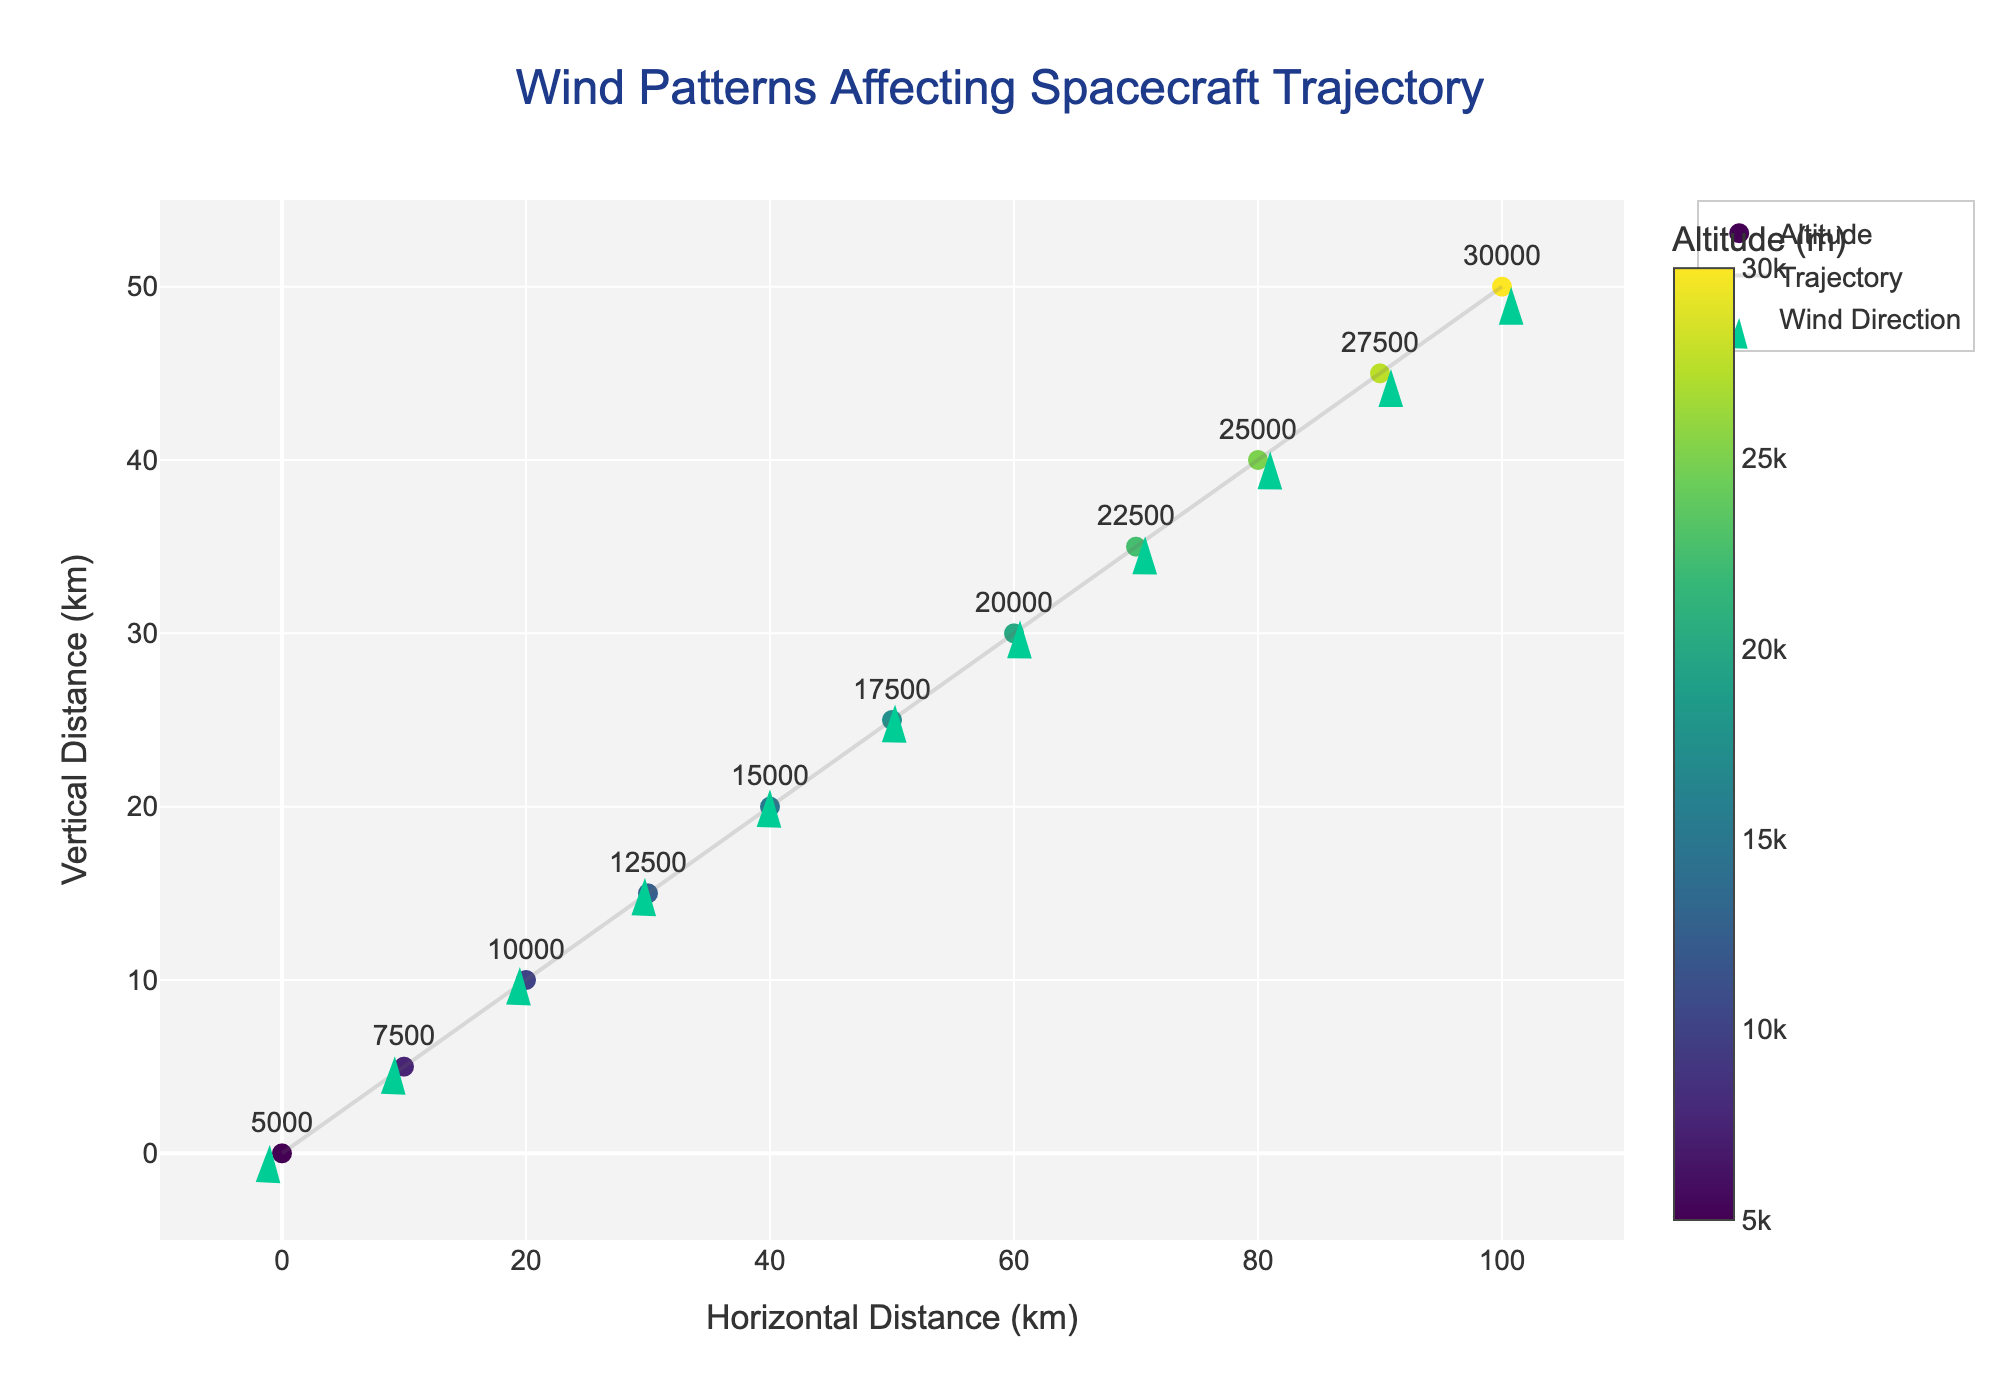How many data points are displayed on the plot? Count the number of distinct markers on the plot. Each marker corresponds to a data point.
Answer: 11 What is the title of the plot? The title is typically located at the top of the plot in a larger font size.
Answer: Wind Patterns Affecting Spacecraft Trajectory Which axis shows horizontal distance? Look at the labels of the axes, the 'Horizontal Distance (km)' label indicates this axis.
Answer: x-axis Which altitude range is represented on the color scale? Observe the color bar alongside the plot; it starts at 5000 meters and ends at 30000 meters.
Answer: 5000 to 30000 meters What is the direction of the wind at the data point where x=40 and y=20? Look at the wind direction arrow at (40, 20). It points directly up, indicating no horizontal component and a vertical movement.
Answer: Upwards Which data point has the strongest wind magnitude? Check the data and observe the magnitude values; the highest magnitude (2.24) occurs at the coordinates (0, 0) and (80, 40).
Answer: (0, 0) and (80, 40) How does the wind direction change as the altitude increases from 5000m to 30000m? Analyze the arrows associated with each data point and their corresponding altitudes on the color scale; the direction shifts from leftwards at lower altitudes to rightwards at higher altitudes.
Answer: Left to right Is there a data point where the wind has no horizontal component? If so, identify the point. Look for a data point where the u component of the wind vector is zero; this happens at (40, 20).
Answer: (40, 20) What is the average magnitude of the wind vectors in the plot? Sum the magnitudes from all data points (2.24 + 1.92 + 1.80 + 1.87 + 2.00 + 1.87 + 1.80 + 1.92 + 2.24 + 1.87 + 1.50) = 21.03, then divide by the number of data points (11).
Answer: 1.91 Which direction are most wind vectors pointing to at higher altitudes? Focus on the wind direction arrows at higher altitudes (color-coded), they predominantly point rightwards.
Answer: Rightwards 